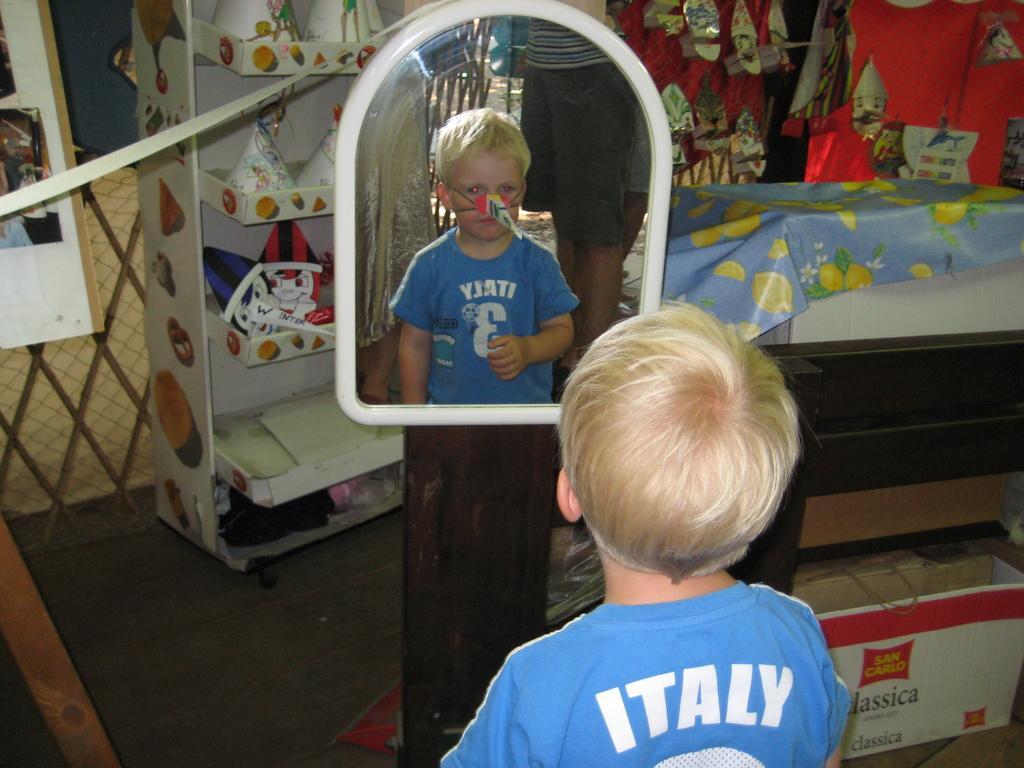Please provide a concise description of this image. In this picture we can see the small boy wearing blue t-shirt, standing in the front and looking in to the mirror. Beside there is a wooden table. Behind we can see the rack with some decorative caps and iron grill. 